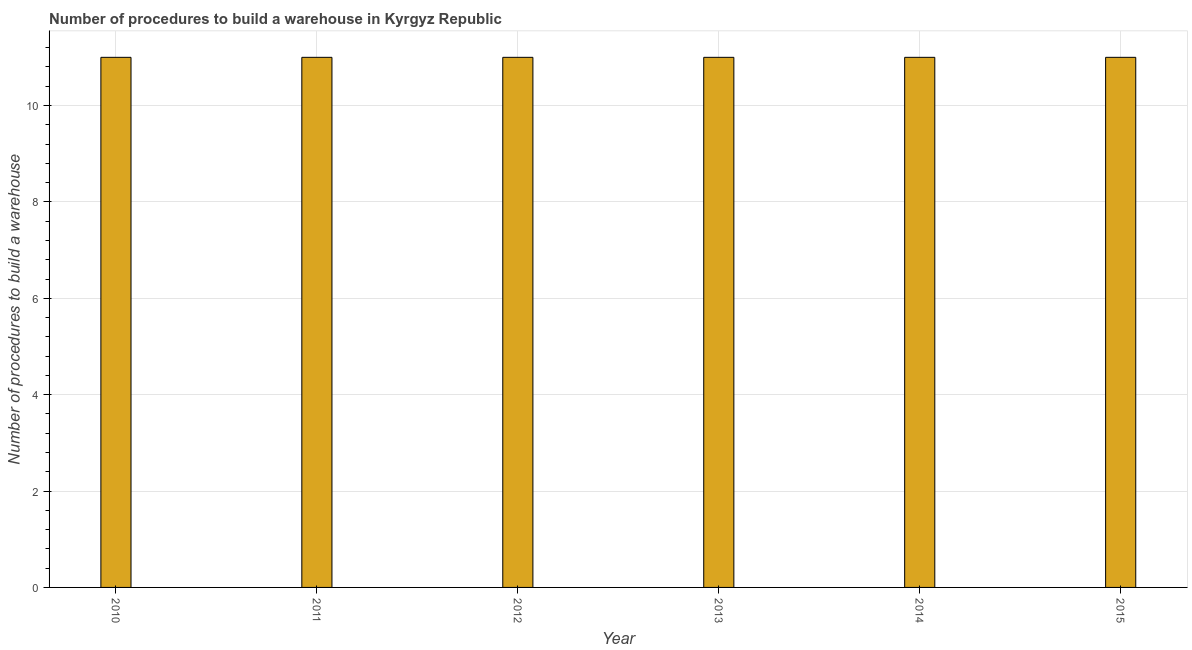Does the graph contain any zero values?
Offer a terse response. No. Does the graph contain grids?
Your answer should be compact. Yes. What is the title of the graph?
Your answer should be compact. Number of procedures to build a warehouse in Kyrgyz Republic. What is the label or title of the Y-axis?
Make the answer very short. Number of procedures to build a warehouse. What is the number of procedures to build a warehouse in 2013?
Make the answer very short. 11. Across all years, what is the maximum number of procedures to build a warehouse?
Your answer should be compact. 11. Across all years, what is the minimum number of procedures to build a warehouse?
Provide a short and direct response. 11. In which year was the number of procedures to build a warehouse maximum?
Provide a short and direct response. 2010. What is the difference between the number of procedures to build a warehouse in 2010 and 2012?
Your answer should be compact. 0. What is the average number of procedures to build a warehouse per year?
Your response must be concise. 11. What is the median number of procedures to build a warehouse?
Ensure brevity in your answer.  11. Is the number of procedures to build a warehouse in 2010 less than that in 2011?
Make the answer very short. No. What is the difference between the highest and the second highest number of procedures to build a warehouse?
Provide a succinct answer. 0. Is the sum of the number of procedures to build a warehouse in 2014 and 2015 greater than the maximum number of procedures to build a warehouse across all years?
Provide a succinct answer. Yes. In how many years, is the number of procedures to build a warehouse greater than the average number of procedures to build a warehouse taken over all years?
Your answer should be compact. 0. Are the values on the major ticks of Y-axis written in scientific E-notation?
Offer a very short reply. No. What is the Number of procedures to build a warehouse in 2010?
Make the answer very short. 11. What is the Number of procedures to build a warehouse in 2011?
Provide a short and direct response. 11. What is the Number of procedures to build a warehouse in 2014?
Keep it short and to the point. 11. What is the difference between the Number of procedures to build a warehouse in 2012 and 2013?
Make the answer very short. 0. What is the difference between the Number of procedures to build a warehouse in 2012 and 2014?
Make the answer very short. 0. What is the difference between the Number of procedures to build a warehouse in 2012 and 2015?
Offer a terse response. 0. What is the difference between the Number of procedures to build a warehouse in 2013 and 2014?
Give a very brief answer. 0. What is the difference between the Number of procedures to build a warehouse in 2013 and 2015?
Your answer should be compact. 0. What is the ratio of the Number of procedures to build a warehouse in 2010 to that in 2011?
Your answer should be compact. 1. What is the ratio of the Number of procedures to build a warehouse in 2010 to that in 2012?
Your response must be concise. 1. What is the ratio of the Number of procedures to build a warehouse in 2010 to that in 2013?
Your answer should be compact. 1. What is the ratio of the Number of procedures to build a warehouse in 2010 to that in 2014?
Make the answer very short. 1. What is the ratio of the Number of procedures to build a warehouse in 2010 to that in 2015?
Provide a succinct answer. 1. What is the ratio of the Number of procedures to build a warehouse in 2011 to that in 2012?
Provide a succinct answer. 1. What is the ratio of the Number of procedures to build a warehouse in 2011 to that in 2013?
Your answer should be very brief. 1. What is the ratio of the Number of procedures to build a warehouse in 2011 to that in 2015?
Give a very brief answer. 1. What is the ratio of the Number of procedures to build a warehouse in 2012 to that in 2013?
Provide a succinct answer. 1. What is the ratio of the Number of procedures to build a warehouse in 2012 to that in 2014?
Your answer should be compact. 1. What is the ratio of the Number of procedures to build a warehouse in 2013 to that in 2014?
Your response must be concise. 1. 